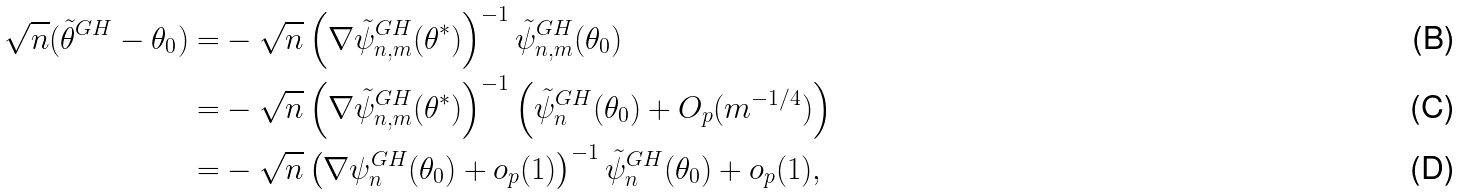<formula> <loc_0><loc_0><loc_500><loc_500>\sqrt { n } ( \tilde { \theta } ^ { G H } - \theta _ { 0 } ) = & - \sqrt { n } \left ( \nabla \tilde { \psi } _ { n , m } ^ { G H } ( \theta ^ { * } ) \right ) ^ { - 1 } \tilde { \psi } _ { n , m } ^ { G H } ( \theta _ { 0 } ) \\ = & - \sqrt { n } \left ( \nabla \tilde { \psi } _ { n , m } ^ { G H } ( \theta ^ { * } ) \right ) ^ { - 1 } \left ( \tilde { \psi } _ { n } ^ { G H } ( \theta _ { 0 } ) + O _ { p } ( m ^ { - 1 / 4 } ) \right ) \\ = & - \sqrt { n } \left ( \nabla \psi _ { n } ^ { G H } ( \theta _ { 0 } ) + o _ { p } ( 1 ) \right ) ^ { - 1 } \tilde { \psi } _ { n } ^ { G H } ( \theta _ { 0 } ) + o _ { p } ( 1 ) ,</formula> 